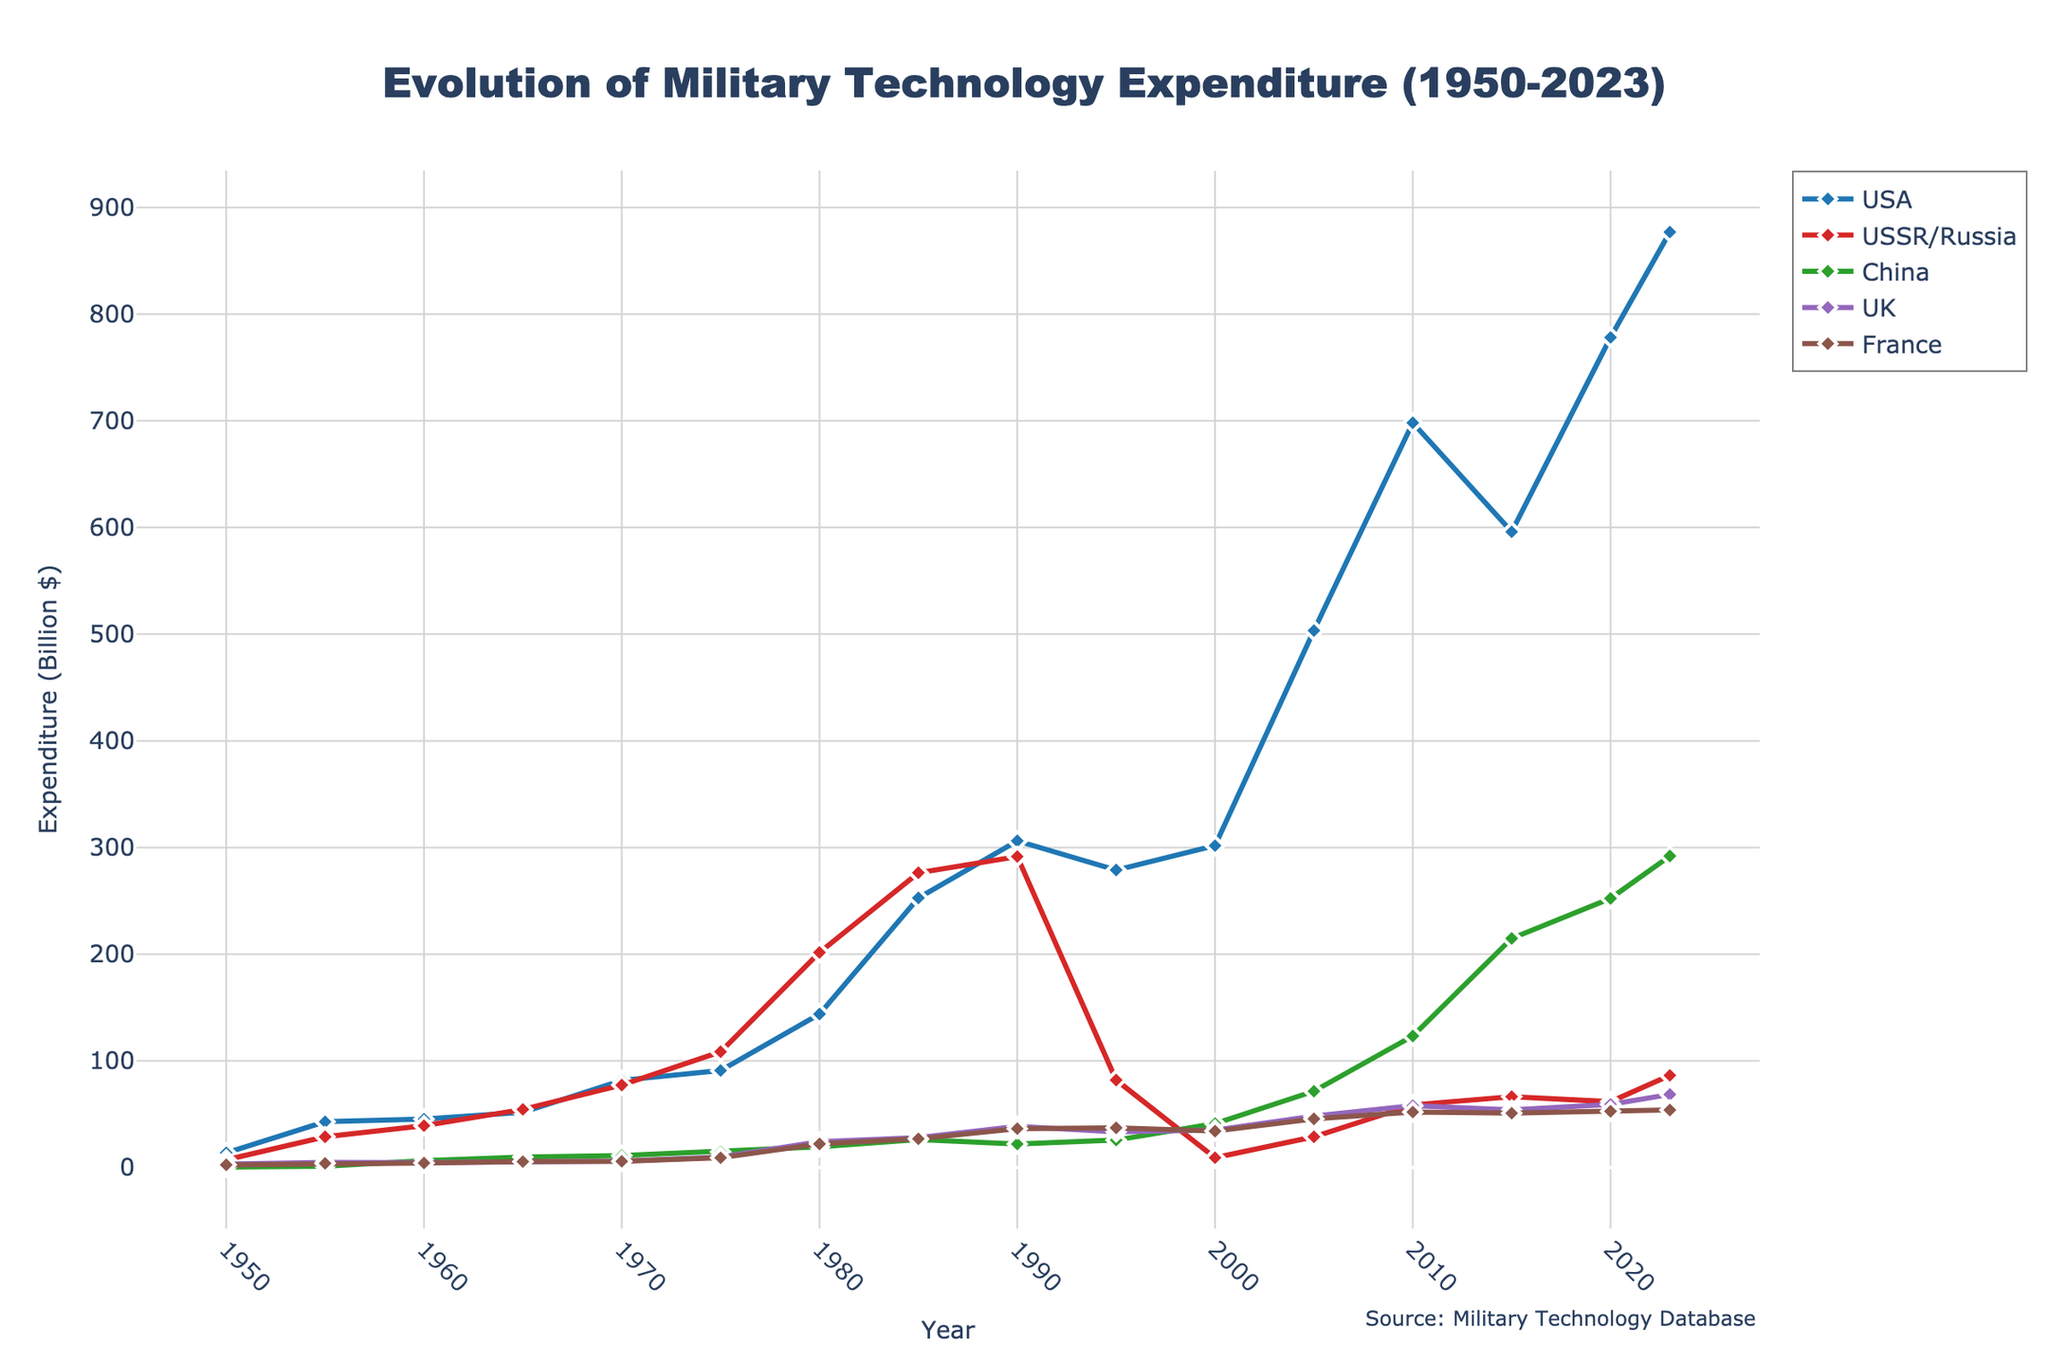What year did the USSR/Russia have the highest military expenditure? Looking at the plot, the peak of the expenditure line for USSR/Russia, which is colored red, appears at 1985. Therefore, 1985 is the year with the highest military expenditure for USSR/Russia.
Answer: 1985 How much was the difference in the military expenditure between the USA and China in 2023? In 2023, the expenditure for the USA is 877 billion dollars and for China is 292 billion dollars. Subtracting these values gives: 877 - 292 = 585 billion dollars.
Answer: 585 billion dollars What is the trend observed for the UK's military expenditure from 1950 to 2023? Observing the UK's line, which is purple, it started from 3.1 billion dollars in 1950, fluctuated over the years, and finally reached 68.5 billion dollars in 2023, showing an overall increasing trend.
Answer: Increasing trend Which country had consistently increasing military expenditure from 2000 to 2023? Examining the trends from 2000 to 2023, both the USA (blue line) and China (green line) show a consistent increase in their military expenditures over this period.
Answer: USA and China In what year did France's military expenditure surpass the UK's, and by how much? Looking at the chart, France's expenditure (brown line) surpassed the UK's (purple line) in 1995. In 1995, France's expenditure was 37.2 billion dollars while the UK's was 33.4 billion dollars. The difference is 37.2 - 33.4 = 3.8 billion dollars.
Answer: 1995, 3.8 billion dollars Calculate the average military expenditure of the USA from 2000 to 2023. USA's expenditure in 2000: 301.7, 2005: 503.4, 2010: 698.2, 2015: 596.0, 2020: 778.2, 2023: 877.0. Sum these values and divide by the number of years (6). So, (301.7 + 503.4 + 698.2 + 596.0 + 778.2 + 877.0) / 6 = 459.1 billion dollars.
Answer: 459.1 billion dollars Which two countries had the closest military expenditure during 1980 and what were those values? In 1980, the USSR/Russia and France had the closest expenditures. USSR/Russia had 201.6 billion dollars and France had 22.1 billion dollars. The closest comparison in larger amounts is incorrect here since distances in smaller magnitudes should be looked at.
Answer: USSR/Russia 201.6 billion dollars, France 22.1 billion dollars How did China's military expenditure change from 1950 to 2023? China’s military expenditure started at 0.4 billion dollars in 1950, steadily increased with significant spikes especially from 2000 onwards reaching 292.0 billion dollars in 2023.
Answer: Significantly increased 